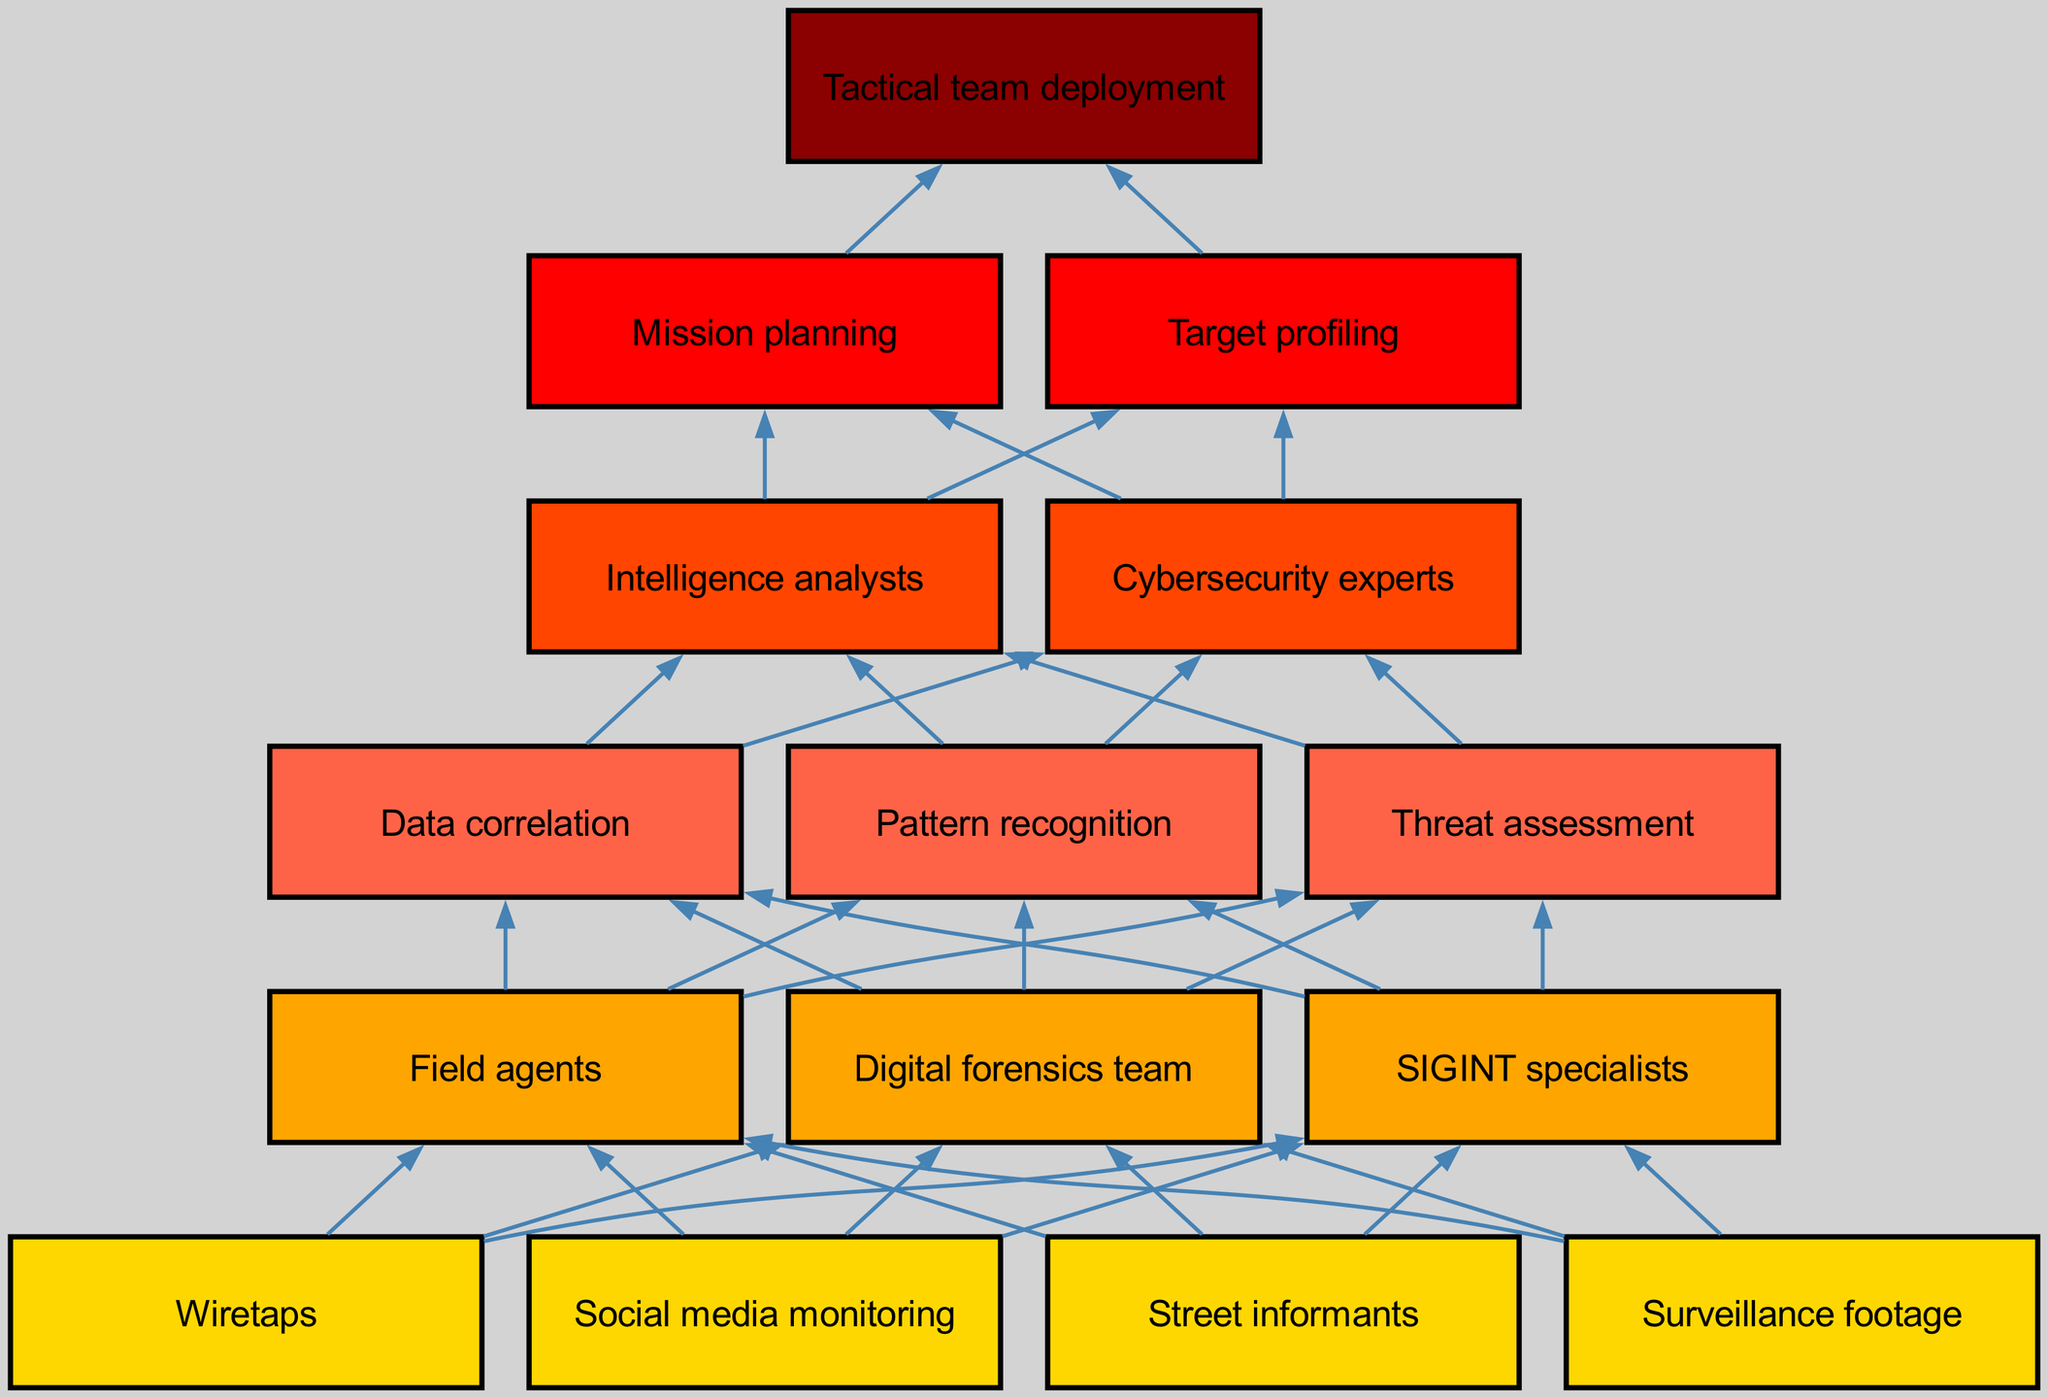What are the first level nodes in the diagram? The first level nodes listed in the diagram are 'Street informants', 'Surveillance footage', 'Wiretaps', and 'Social media monitoring'. This information can be found directly in the data for level 1.
Answer: Street informants, Surveillance footage, Wiretaps, Social media monitoring How many nodes are in level 3? Level 3 contains three nodes: 'Data correlation', 'Pattern recognition', and 'Threat assessment'. The count can be determined by simply reviewing the number of entries in the level data.
Answer: 3 What connects 'Street informants' to 'Field agents'? The connection is made through the flow chart's directed edges from level 1 to level 2. 'Street informants' is on level 1, and 'Field agents' is on level 2, making it one of the key paths for information flow.
Answer: Field agents Which node is directly above 'Target profiling'? The node directly above 'Target profiling' is 'Intelligence analysts', which is in level 4. This can be determined from the hierarchical structure of the flow chart.
Answer: Intelligence analysts How many edges are there between level 2 and level 3? Each node in level 2 ('Field agents', 'Digital forensics team', 'SIGINT specialists') connects to each node in level 3 ('Data correlation', 'Pattern recognition', 'Threat assessment'). There are three nodes in level 2 and three nodes in level 3, leading to a total of 9 edges.
Answer: 9 What is the final outcome in the intelligence gathering process? The final outcome is 'Tactical team deployment', which is the only node in level 6, representing the culmination of the entire intelligence gathering process as depicted in the flow chart.
Answer: Tactical team deployment How does 'Surveillance footage' link to 'Threat assessment'? 'Surveillance footage' connects to 'Field agents' in level 2, which then connects to 'Data correlation' and subsequently to 'Threat assessment' in level 3, showing the layered process of intelligence gathering.
Answer: Through data correlation Which two nodes from level 4 lead to actions in level 5? The two nodes from level 4 leading to actions in level 5 are 'Intelligence analysts' and 'Cybersecurity experts.' Both contribute to the processes of 'Mission planning' and 'Target profiling'.
Answer: Intelligence analysts, Cybersecurity experts 